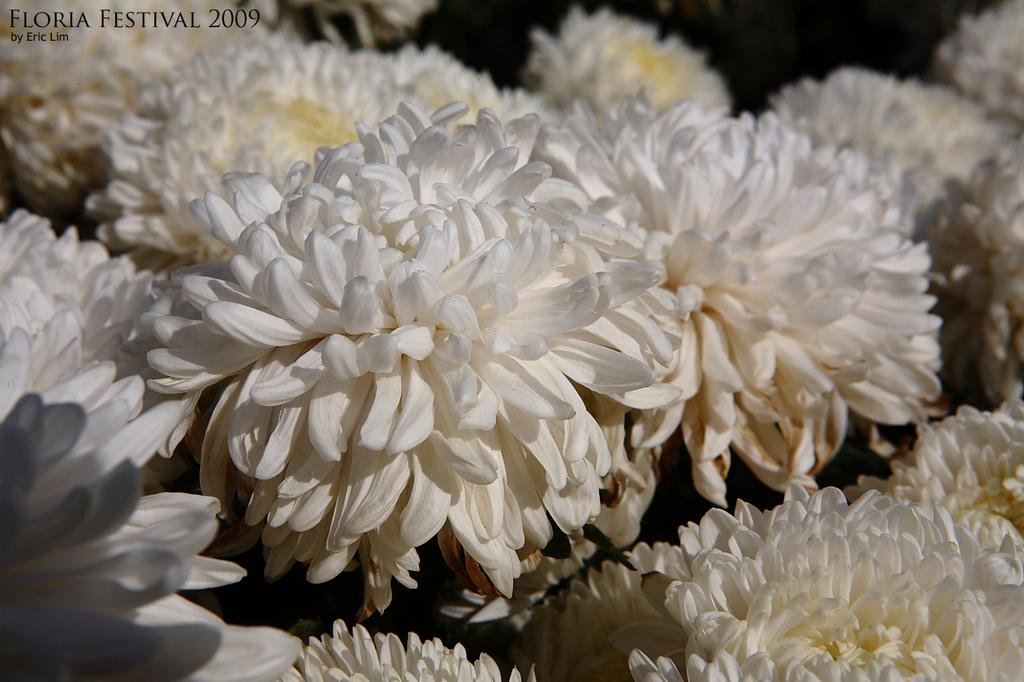What type of flora is present in the image? There are flowers in the image. What color are the flowers? The flowers are white. Is there any text present in the image? Yes, there is text visible on the image. How many ants can be seen crawling on the chin in the image? There are no ants or chins present in the image; it features white flowers and text. 